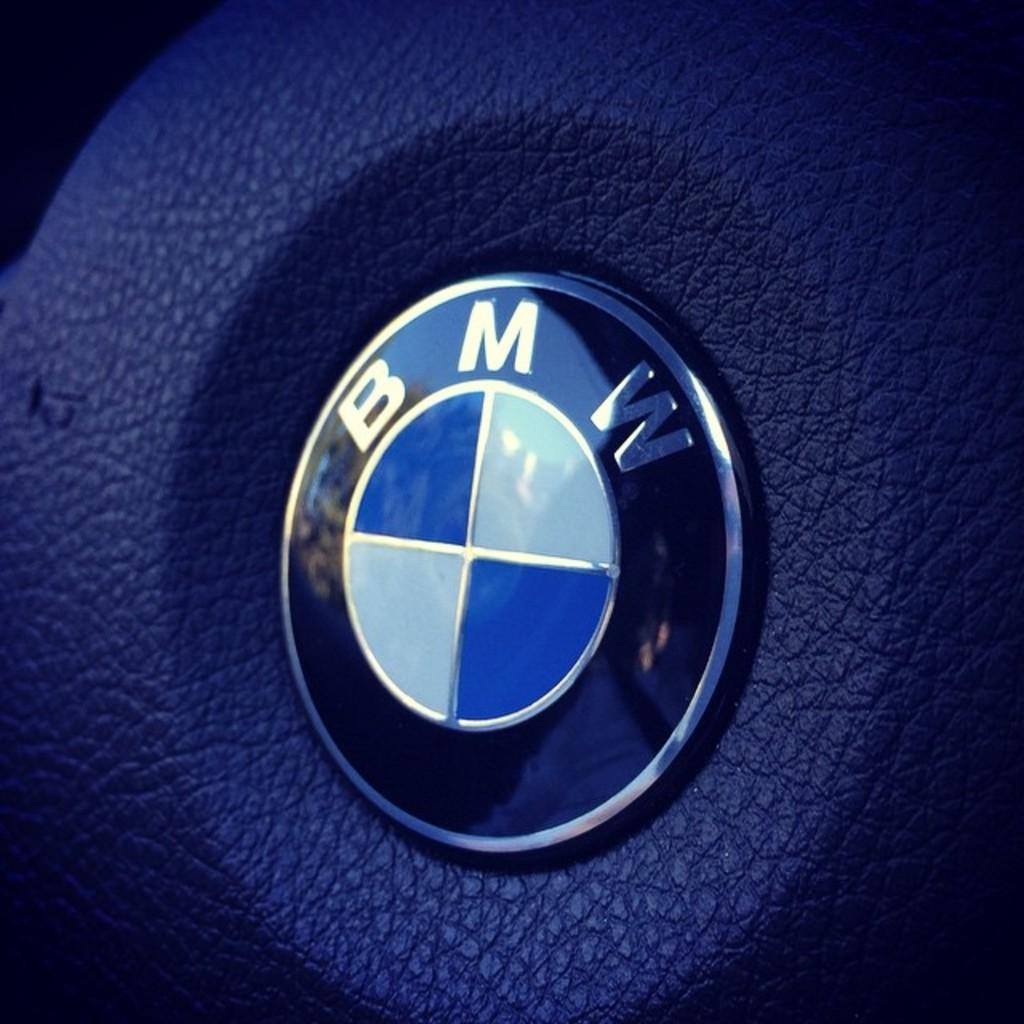What is the main feature of the image? There is a logo in the image. What color is the background of the image? The background of the image is blue. What type of pear is being advertised in the image? There is no pear or advertisement present in the image; it only features a logo and a blue background. 